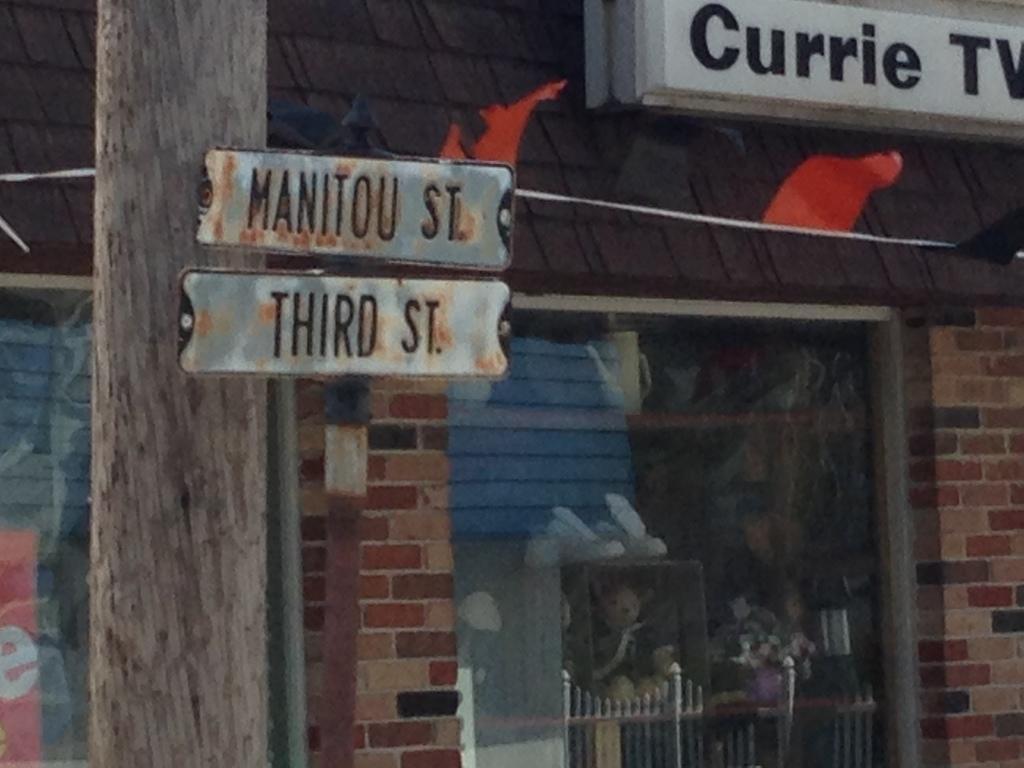In one or two sentences, can you explain what this image depicts? In this picture we can observe two boards fixed to this red color pole on the left side. There is a tree. We can observe white color board fixed to the wall of this building. In the background there is a building. 